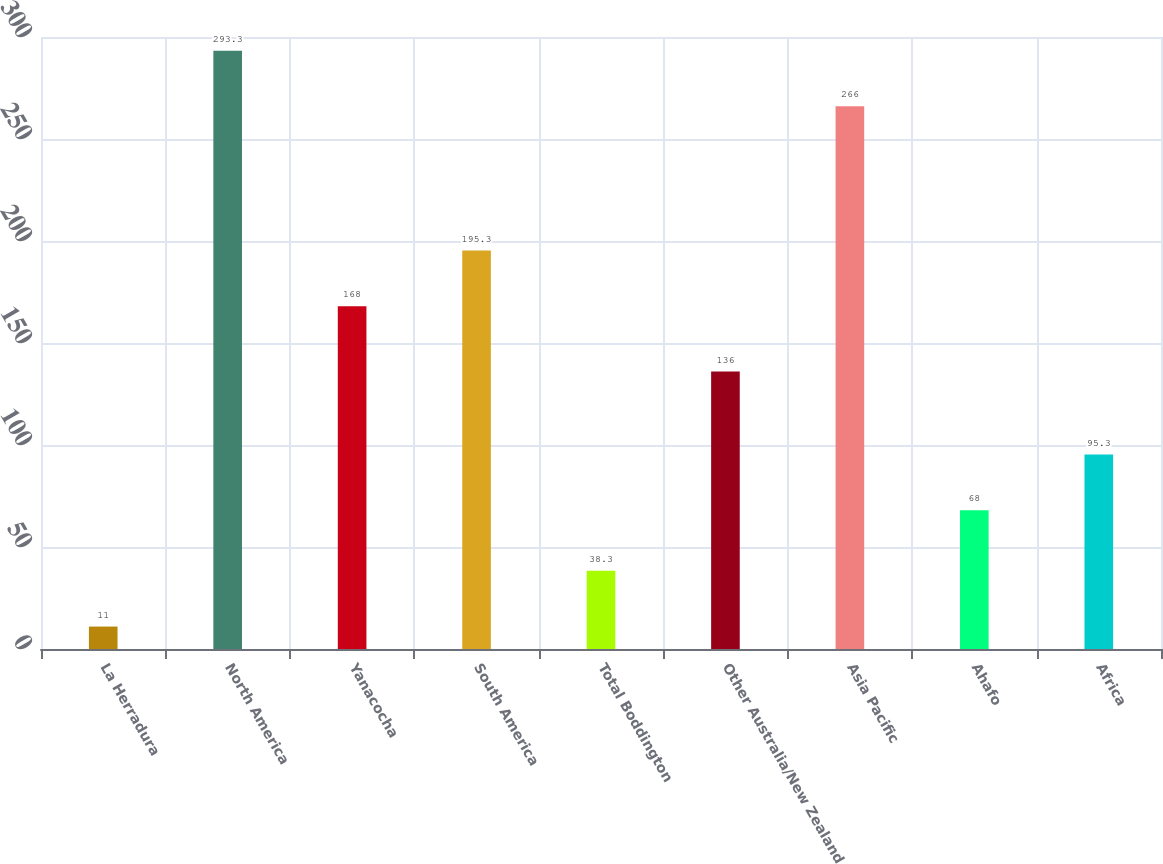Convert chart. <chart><loc_0><loc_0><loc_500><loc_500><bar_chart><fcel>La Herradura<fcel>North America<fcel>Yanacocha<fcel>South America<fcel>Total Boddington<fcel>Other Australia/New Zealand<fcel>Asia Pacific<fcel>Ahafo<fcel>Africa<nl><fcel>11<fcel>293.3<fcel>168<fcel>195.3<fcel>38.3<fcel>136<fcel>266<fcel>68<fcel>95.3<nl></chart> 